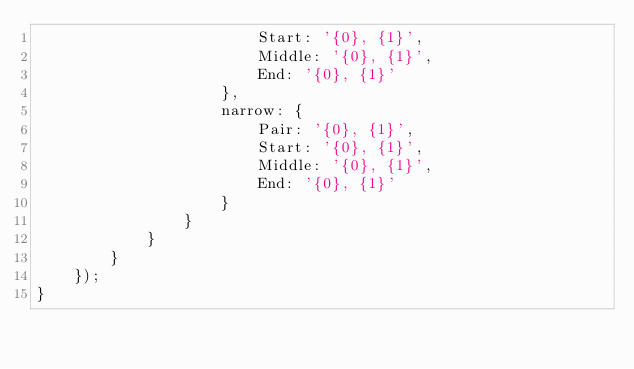<code> <loc_0><loc_0><loc_500><loc_500><_JavaScript_>                        Start: '{0}, {1}',
                        Middle: '{0}, {1}',
                        End: '{0}, {1}'
                    },
                    narrow: {
                        Pair: '{0}, {1}',
                        Start: '{0}, {1}',
                        Middle: '{0}, {1}',
                        End: '{0}, {1}'
                    }
                }
            }
        }
    });
}
</code> 